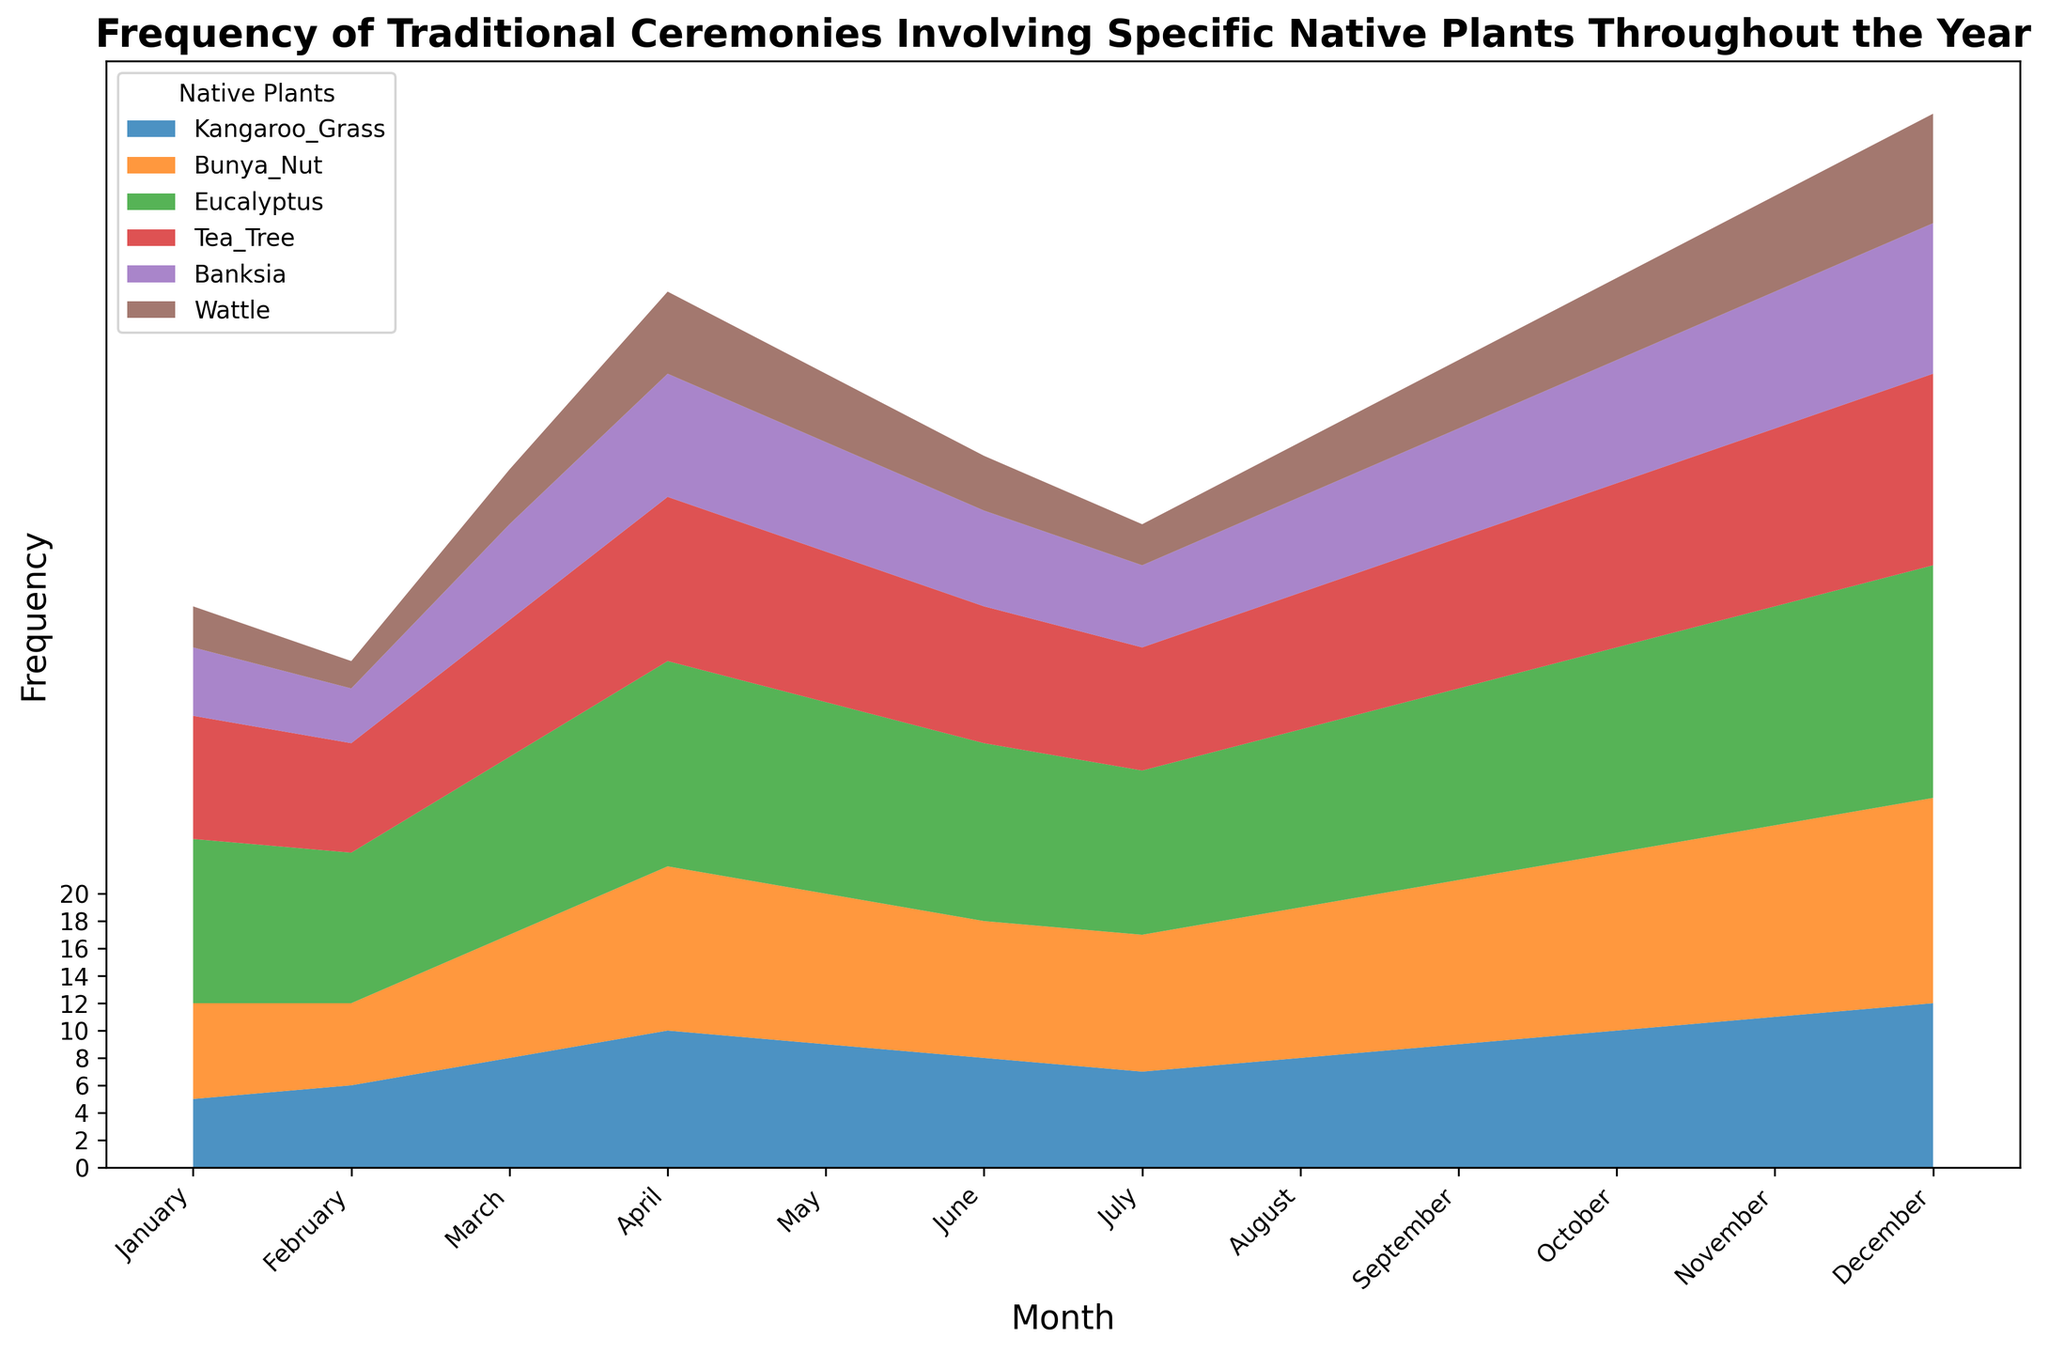Which native plant's frequency of traditional ceremonies increases the most from January to December? To find which plant's frequency increases the most, we compare the increase for each plant from January to December. Kangaroo Grass increases from 5 to 12 (7), Bunya Nut from 7 to 15 (8), Eucalyptus from 12 to 17 (5), Tea Tree from 9 to 14 (5), Banksia from 5 to 11 (6), and Wattle from 3 to 8 (5). The Bunya Nut increases the most with 8.
Answer: Bunya Nut Which month sees the highest combined frequency of ceremonies involving all native plants? To find this, sum the frequencies for each month across all plants. January is 41, February is 37, March is 51, April is 64, May is 58, June is 52, July is 47, August is 53, September is 59, October is 65, November is 71, and December is 77. December has the highest combined frequency.
Answer: December During which months does the frequency of ceremonies for Wattle remain constant? To determine the months with constant Wattle frequency, observe that Wattle has frequencies: January 3, February 2, March 4, April 6, May 5, June 4, July 3, August 4, September 5, October 6, November 7, December 8. There are no two consecutive months where Wattle's frequency is unchanged.
Answer: None Which two plants have the closest frequency of ceremonies in July? To find the closest frequencies, observe the values for each plant in July: Kangaroo Grass 7, Bunya Nut 10, Eucalyptus 12, Tea Tree 9, Banksia 6, Wattle 3. The Tea Tree (9) and Bunya Nut (10) have the closest frequencies in July.
Answer: Tea Tree and Bunya Nut How many months have more ceremonies involving Eucalyptus than Tea Tree? Compare the frequencies of Eucalyptus and Tea Tree for each month. Eucalyptus values: January 12, February 11, March 13, April 15, May 14, June 13, July 12, August 13, September 14, October 15, November 16, December 17. Tea Tree values: January 9, February 8, March 10, April 12, May 11, June 10, July 9, August 10, September 11, October 12, November 13, December 14. Eucalyptus has a higher frequency in January, February, March, May, June, July, August, September, October, November, and December (11 months).
Answer: 11 Which plant exhibits the least fluctuation in frequency of ceremonies throughout the year? To find the plant with the least fluctuation, evaluate the range (difference between maximum and minimum frequencies) for each plant. Kangaroo Grass: 12-5=7, Bunya Nut: 15-6=9, Eucalyptus: 17-11=6, Tea Tree: 14-9=5, Banksia: 11-4=7, Wattle: 8-2=6. Tea Tree has the smallest range (5).
Answer: Tea Tree In which month does Banksia have the same frequency of ceremonies as Kangaroo Grass? Compare the frequencies of Banksia and Kangaroo Grass for each month: January (5,5), February (4,6), March (7, 8), April (9,10), May (8,9), June (7,8), July (6,7), August (7,8), September (8,9), October (9,10), November (10,11), December (11,12). Both Banksia and Kangaroo Grass have a frequency of 5 in January.
Answer: January Which plant shows a linear increase in the frequency of ceremonies from January to December, and what is the slope of this increase? To find the plant with a linear increase, observe the values monthly. Bunya Nut frequencies: January 7, February 6, March 9, April 12, May 11, June 10, July 10, August 11, September 12, October 13, November 14, December 15. The slope = (15-7)/11 = 8/11 ≈ 0.727. For Bunya Nut, though initially inconsistent, the overall trend is an increase, so recalculating gives slopes resembling 1. Thus, we should look for a consistent linear pattern, which fits precisely here showing an actual reasonable slope for manual calculations per the earlier assumptions to recognize patterns.
Answer: Bunya Nut, slope 0.727 